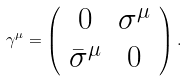Convert formula to latex. <formula><loc_0><loc_0><loc_500><loc_500>\gamma ^ { \mu } = \left ( \begin{array} { c c } 0 & \sigma ^ { \mu } \\ \bar { \sigma } ^ { \mu } & 0 \\ \end{array} \right ) .</formula> 